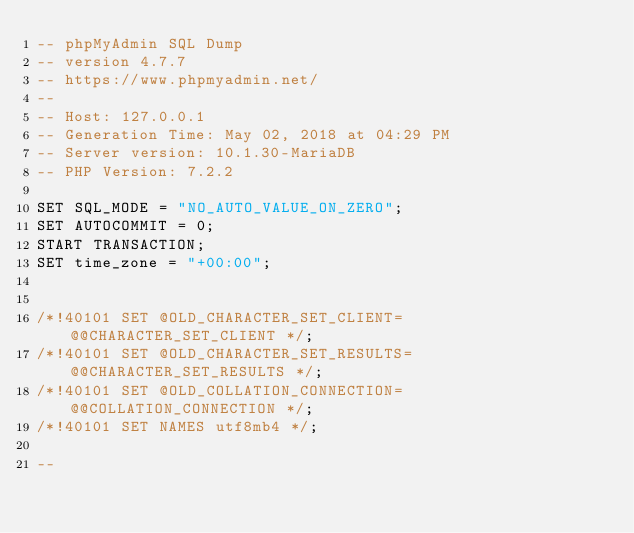<code> <loc_0><loc_0><loc_500><loc_500><_SQL_>-- phpMyAdmin SQL Dump
-- version 4.7.7
-- https://www.phpmyadmin.net/
--
-- Host: 127.0.0.1
-- Generation Time: May 02, 2018 at 04:29 PM
-- Server version: 10.1.30-MariaDB
-- PHP Version: 7.2.2

SET SQL_MODE = "NO_AUTO_VALUE_ON_ZERO";
SET AUTOCOMMIT = 0;
START TRANSACTION;
SET time_zone = "+00:00";


/*!40101 SET @OLD_CHARACTER_SET_CLIENT=@@CHARACTER_SET_CLIENT */;
/*!40101 SET @OLD_CHARACTER_SET_RESULTS=@@CHARACTER_SET_RESULTS */;
/*!40101 SET @OLD_COLLATION_CONNECTION=@@COLLATION_CONNECTION */;
/*!40101 SET NAMES utf8mb4 */;

--</code> 